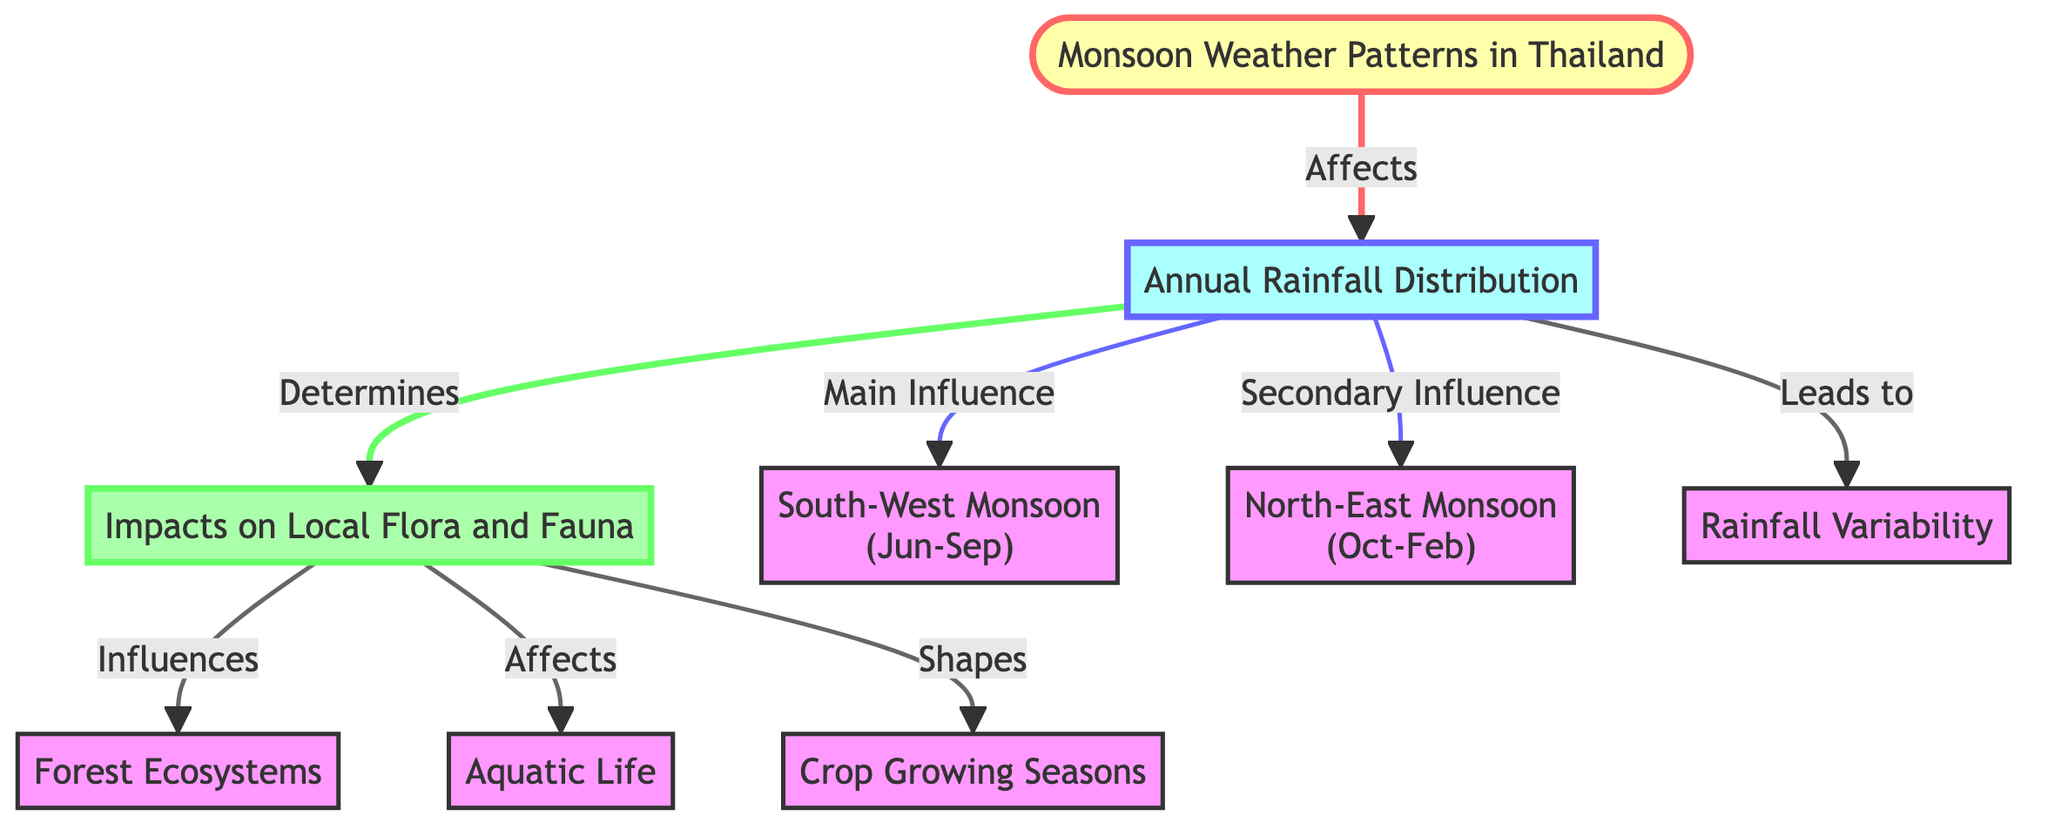What's the main influence on annual rainfall distribution? The diagram indicates that the main influence on annual rainfall distribution is the South-West Monsoon, which directly connects to the Annual Rainfall Distribution node.
Answer: South-West Monsoon What are the two types of monsoons affecting Thailand? The diagram shows two monsoon types: South-West Monsoon and North-East Monsoon, represented as separate nodes connected to the Annual Rainfall Distribution.
Answer: South-West Monsoon and North-East Monsoon What does annual rainfall lead to? According to the diagram, annual rainfall leads to rainfall variability, as indicated by the direct connection from the Annual Rainfall Distribution node to the Rainfall Variability node.
Answer: Rainfall Variability How does rainfall influence local flora and fauna? The diagram shows that annual rainfall determines the impacts on local flora and fauna, highlighting the link between these two nodes, suggesting rainfall is a key factor.
Answer: Determines What influences forest ecosystems? The diagram indicates that the impacts on local flora and fauna influence forest ecosystems, illustrated by the connection from the Flora Fauna Impacts node to the Forest Ecosystems node.
Answer: Influences What is shaped by the impacts on local flora and fauna? Looking at the diagram, we can see that the impacts on local flora and fauna shape crop growing seasons, establishing a direct connection between these nodes.
Answer: Shapes How many main components does the diagram have? The diagram comprises three main components: Monsoon Weather Patterns, Annual Rainfall Distribution, and Impacts on Local Flora and Fauna, totaling three distinct nodes.
Answer: Three Which monsoon lasts from October to February? By examining the diagram, we can determine that the North-East Monsoon lasts from October to February, directly stated next to its corresponding node.
Answer: North-East Monsoon What does the rainfall variability node represent? The rainfall variability node represents the variations in rainfall patterns that are influenced by the overall annual rainfall, as shown in the connection to the Annual Rainfall Distribution.
Answer: Variability 